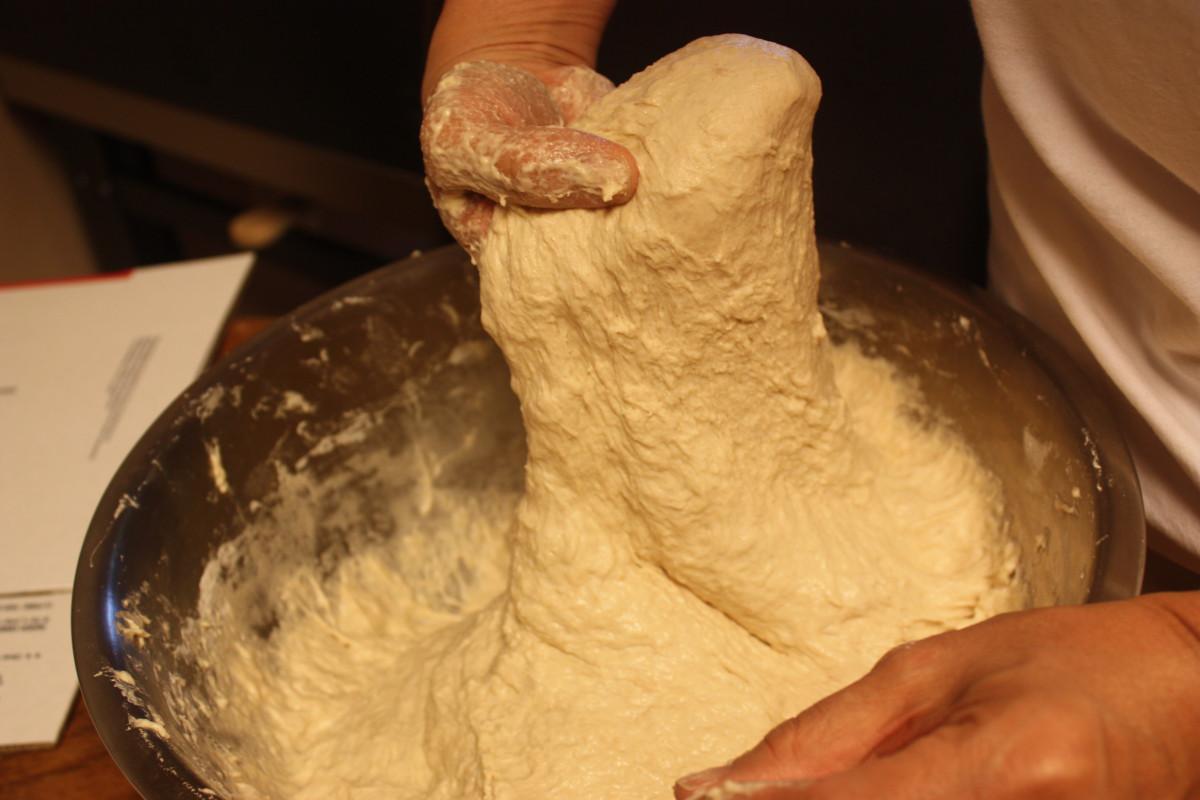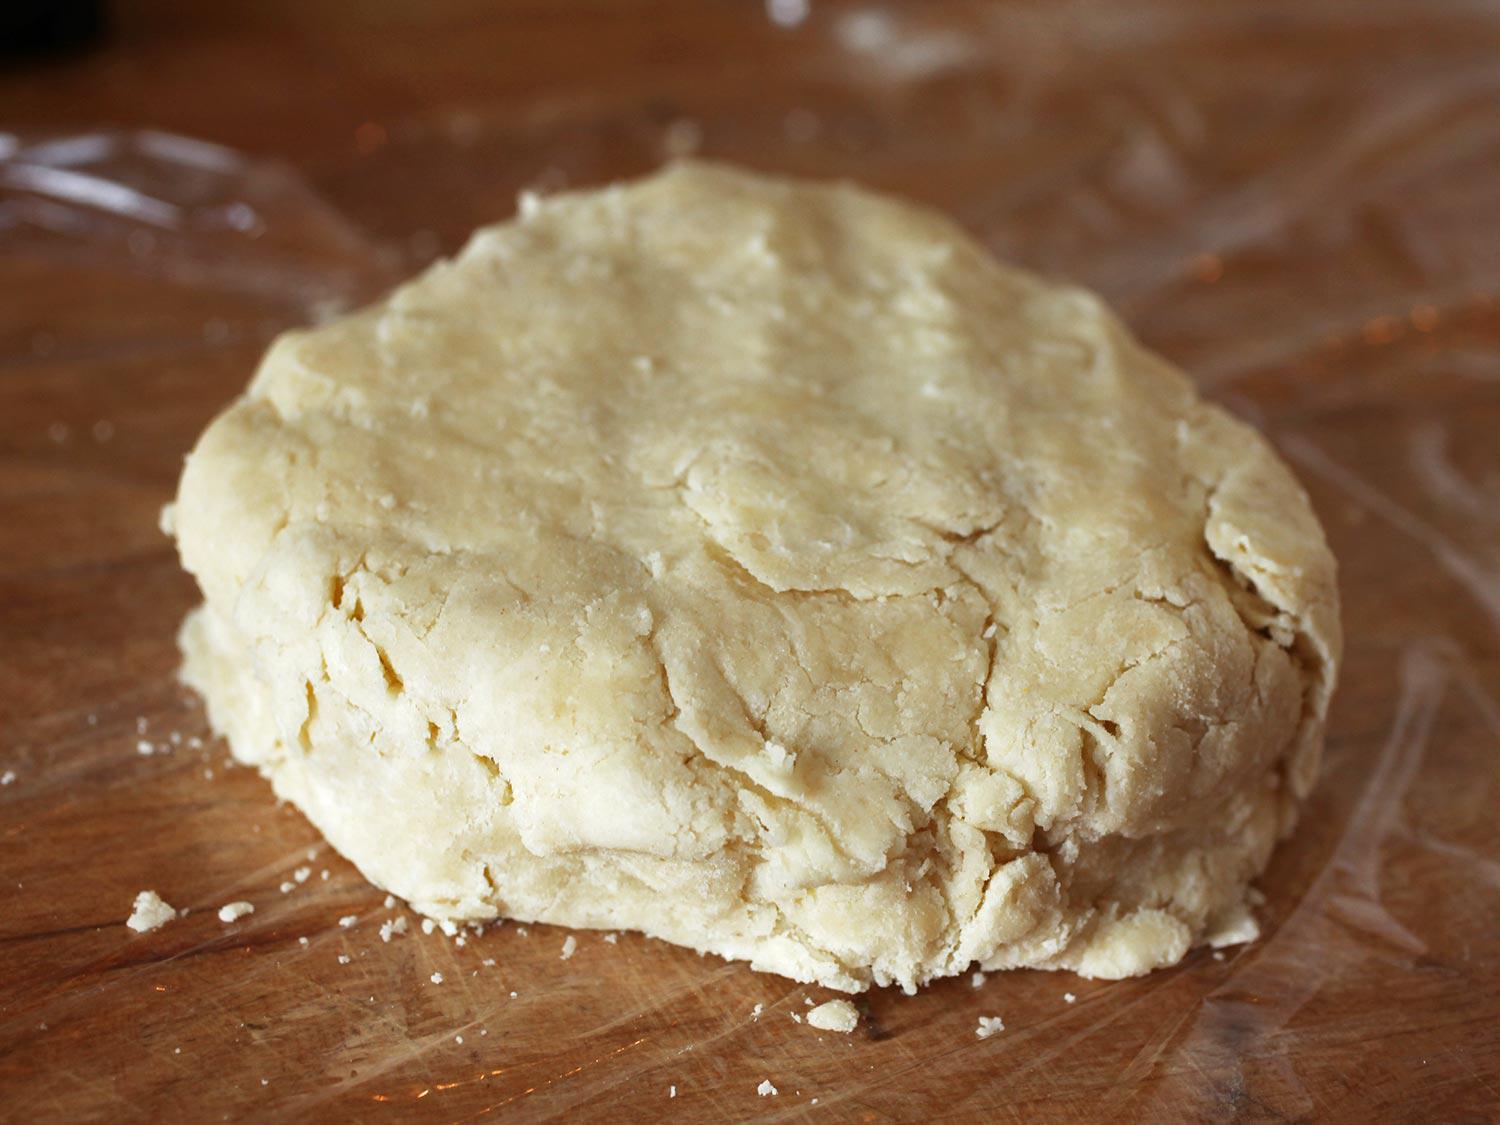The first image is the image on the left, the second image is the image on the right. Examine the images to the left and right. Is the description "A person has their hands in the dough in one picture but not the other." accurate? Answer yes or no. Yes. The first image is the image on the left, the second image is the image on the right. For the images displayed, is the sentence "Dough is rolled into a round ball in the image on the right." factually correct? Answer yes or no. No. 